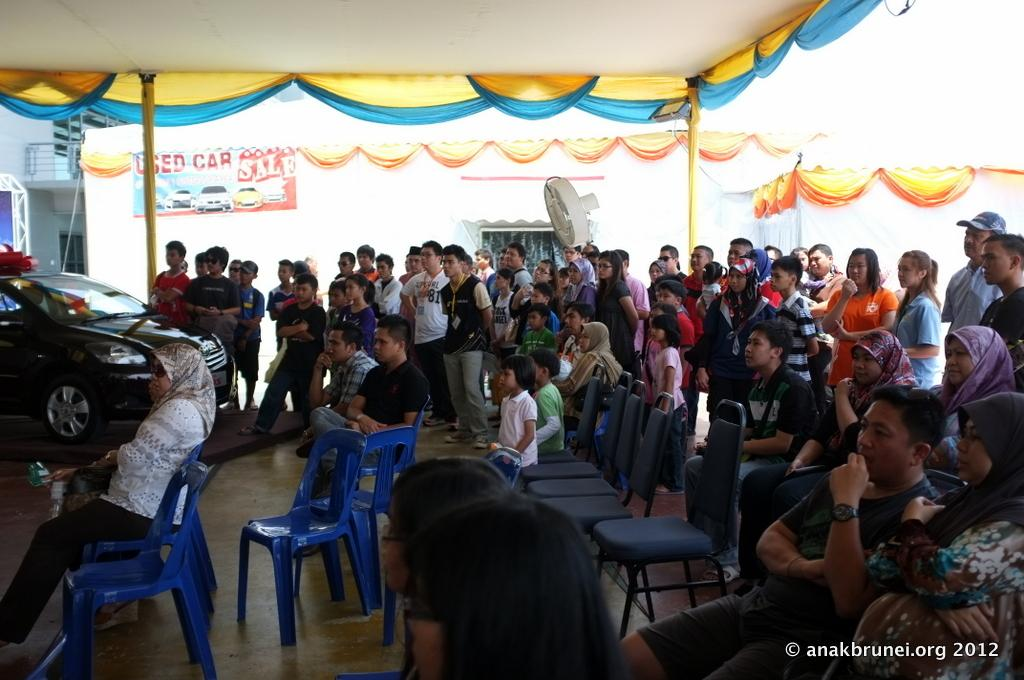What are the people in the image doing? The persons standing on the floor in the image are likely standing or waiting. What objects are present for sitting in the image? There are chairs in the image. What type of vehicle can be seen in the image? There is a vehicle in the image. What can be seen in the background of the image? There is a wall and a pole in the background of the image. What color is the sock on the pole in the image? There is no sock present in the image, and the pole is not mentioned to have any sock on it. 